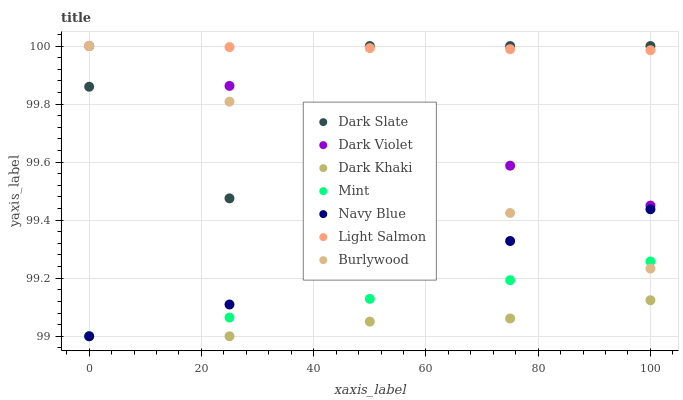Does Dark Khaki have the minimum area under the curve?
Answer yes or no. Yes. Does Light Salmon have the maximum area under the curve?
Answer yes or no. Yes. Does Burlywood have the minimum area under the curve?
Answer yes or no. No. Does Burlywood have the maximum area under the curve?
Answer yes or no. No. Is Burlywood the smoothest?
Answer yes or no. Yes. Is Dark Slate the roughest?
Answer yes or no. Yes. Is Navy Blue the smoothest?
Answer yes or no. No. Is Navy Blue the roughest?
Answer yes or no. No. Does Navy Blue have the lowest value?
Answer yes or no. Yes. Does Burlywood have the lowest value?
Answer yes or no. No. Does Dark Slate have the highest value?
Answer yes or no. Yes. Does Navy Blue have the highest value?
Answer yes or no. No. Is Mint less than Dark Slate?
Answer yes or no. Yes. Is Dark Violet greater than Mint?
Answer yes or no. Yes. Does Mint intersect Navy Blue?
Answer yes or no. Yes. Is Mint less than Navy Blue?
Answer yes or no. No. Is Mint greater than Navy Blue?
Answer yes or no. No. Does Mint intersect Dark Slate?
Answer yes or no. No. 